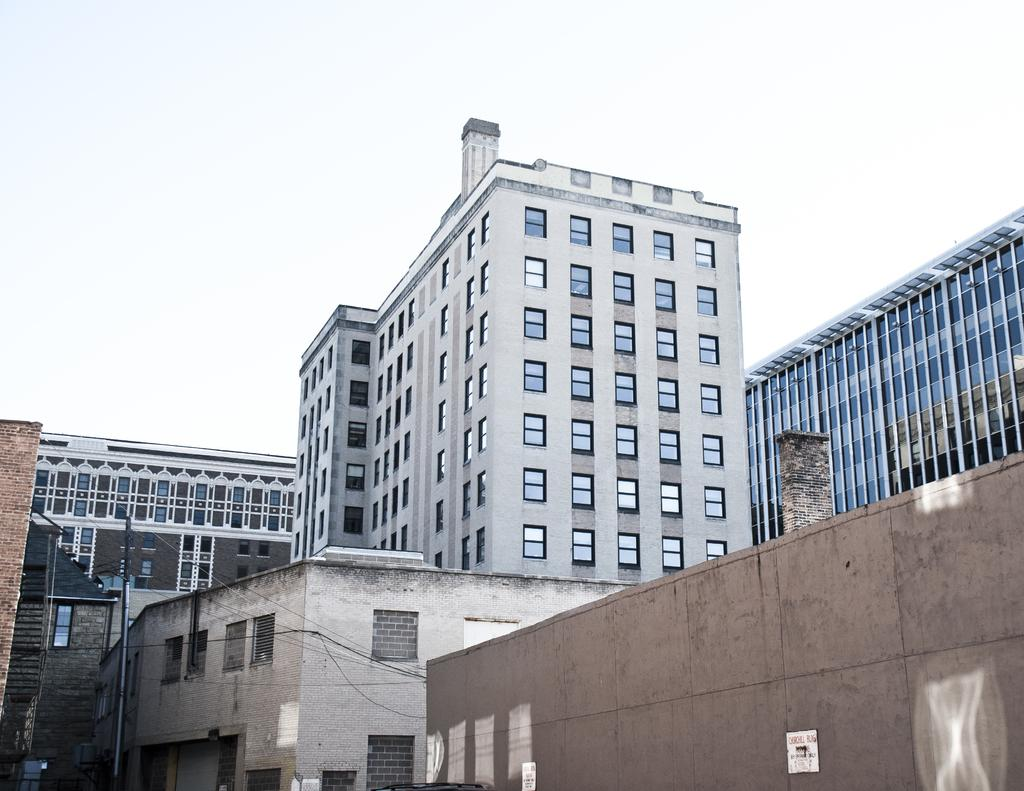What is located on the left side of the image? There is a pole with electrical wires on the left side of the image. What type of structures can be seen in the image? There are big buildings in the image. What is the condition of the sky in the image? The sky is cloudy at the top of the image. What type of crime is being committed in the image? There is no indication of any crime being committed in the image. What color is the sheet draped over the patch in the image? There is no sheet or patch present in the image. 